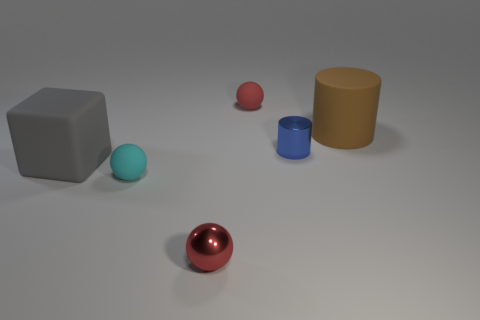What number of things are objects on the left side of the tiny red matte ball or blue things?
Keep it short and to the point. 4. There is a rubber object that is the same color as the tiny shiny sphere; what size is it?
Offer a terse response. Small. There is a shiny cylinder behind the gray block; is it the same color as the tiny matte sphere in front of the blue thing?
Your answer should be very brief. No. How big is the red metal ball?
Offer a very short reply. Small. What number of small objects are gray cubes or matte balls?
Keep it short and to the point. 2. What is the color of the block that is the same size as the brown cylinder?
Your answer should be compact. Gray. How many other things are the same shape as the gray object?
Your response must be concise. 0. Are there any red balls that have the same material as the tiny cyan sphere?
Make the answer very short. Yes. Are the red thing that is to the left of the red matte object and the cyan thing in front of the large cylinder made of the same material?
Your response must be concise. No. How many large cyan things are there?
Your answer should be compact. 0. 